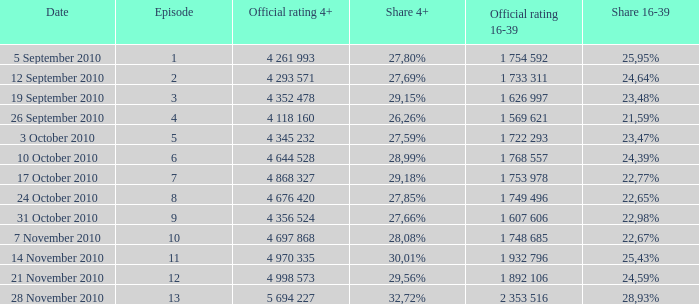77%? 1 753 978. 